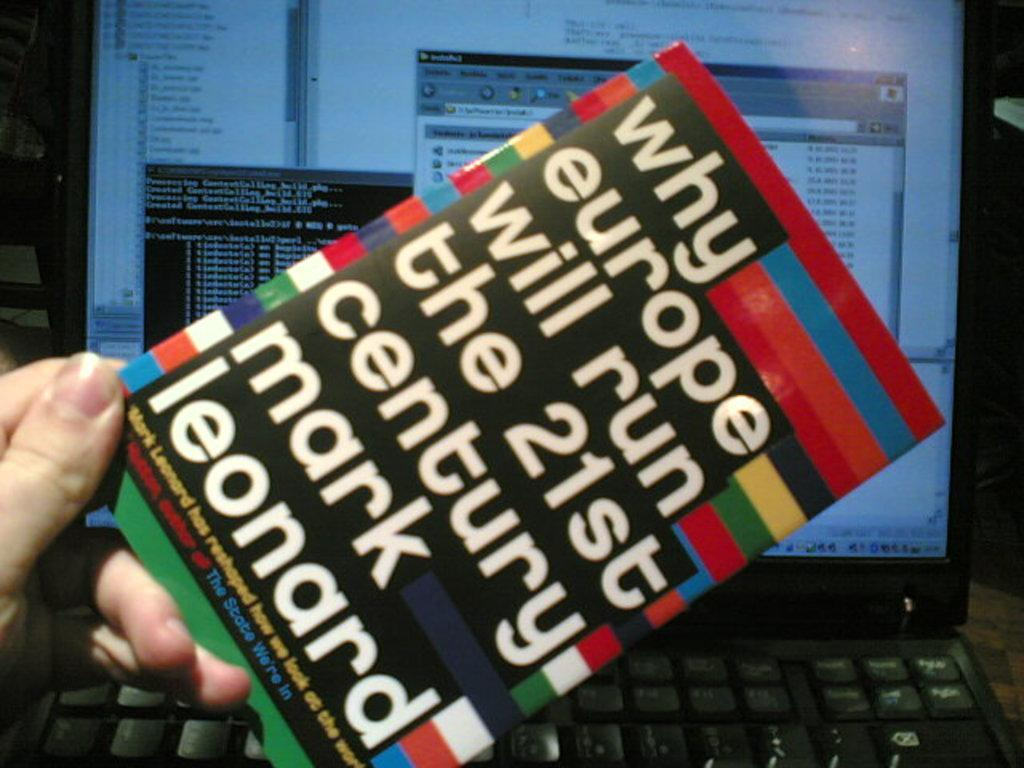<image>
Render a clear and concise summary of the photo. Mark Leonard's book is about why Europe will run this century. 